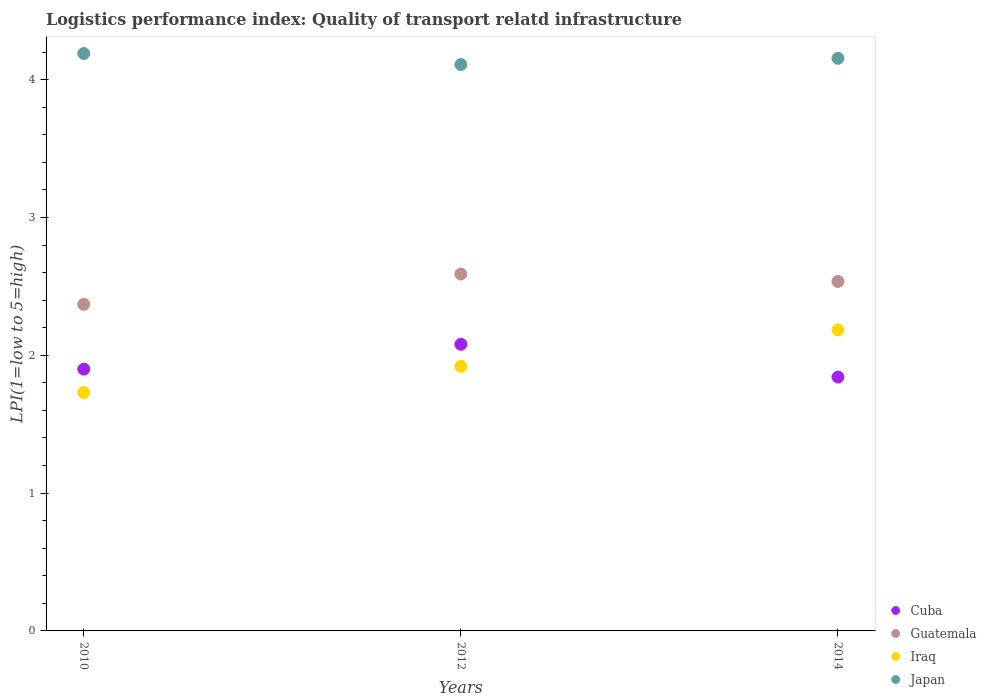How many different coloured dotlines are there?
Provide a succinct answer. 4. Is the number of dotlines equal to the number of legend labels?
Your answer should be very brief. Yes. What is the logistics performance index in Japan in 2014?
Make the answer very short. 4.16. Across all years, what is the maximum logistics performance index in Iraq?
Ensure brevity in your answer.  2.18. Across all years, what is the minimum logistics performance index in Cuba?
Give a very brief answer. 1.84. In which year was the logistics performance index in Guatemala maximum?
Ensure brevity in your answer.  2012. What is the total logistics performance index in Guatemala in the graph?
Your answer should be compact. 7.5. What is the difference between the logistics performance index in Guatemala in 2012 and that in 2014?
Your response must be concise. 0.05. What is the difference between the logistics performance index in Cuba in 2014 and the logistics performance index in Iraq in 2012?
Offer a very short reply. -0.08. What is the average logistics performance index in Cuba per year?
Provide a succinct answer. 1.94. In the year 2010, what is the difference between the logistics performance index in Iraq and logistics performance index in Japan?
Your answer should be compact. -2.46. In how many years, is the logistics performance index in Iraq greater than 0.2?
Your answer should be very brief. 3. What is the ratio of the logistics performance index in Iraq in 2012 to that in 2014?
Ensure brevity in your answer.  0.88. Is the difference between the logistics performance index in Iraq in 2012 and 2014 greater than the difference between the logistics performance index in Japan in 2012 and 2014?
Ensure brevity in your answer.  No. What is the difference between the highest and the second highest logistics performance index in Cuba?
Provide a succinct answer. 0.18. What is the difference between the highest and the lowest logistics performance index in Iraq?
Your answer should be compact. 0.45. Does the logistics performance index in Guatemala monotonically increase over the years?
Keep it short and to the point. No. How many dotlines are there?
Keep it short and to the point. 4. What is the difference between two consecutive major ticks on the Y-axis?
Ensure brevity in your answer.  1. Does the graph contain grids?
Make the answer very short. No. How many legend labels are there?
Offer a terse response. 4. What is the title of the graph?
Give a very brief answer. Logistics performance index: Quality of transport relatd infrastructure. What is the label or title of the Y-axis?
Keep it short and to the point. LPI(1=low to 5=high). What is the LPI(1=low to 5=high) in Guatemala in 2010?
Keep it short and to the point. 2.37. What is the LPI(1=low to 5=high) of Iraq in 2010?
Provide a short and direct response. 1.73. What is the LPI(1=low to 5=high) of Japan in 2010?
Provide a short and direct response. 4.19. What is the LPI(1=low to 5=high) in Cuba in 2012?
Provide a succinct answer. 2.08. What is the LPI(1=low to 5=high) in Guatemala in 2012?
Offer a very short reply. 2.59. What is the LPI(1=low to 5=high) of Iraq in 2012?
Keep it short and to the point. 1.92. What is the LPI(1=low to 5=high) in Japan in 2012?
Your answer should be very brief. 4.11. What is the LPI(1=low to 5=high) in Cuba in 2014?
Provide a succinct answer. 1.84. What is the LPI(1=low to 5=high) of Guatemala in 2014?
Your answer should be compact. 2.54. What is the LPI(1=low to 5=high) in Iraq in 2014?
Offer a terse response. 2.18. What is the LPI(1=low to 5=high) in Japan in 2014?
Offer a terse response. 4.16. Across all years, what is the maximum LPI(1=low to 5=high) of Cuba?
Provide a short and direct response. 2.08. Across all years, what is the maximum LPI(1=low to 5=high) in Guatemala?
Keep it short and to the point. 2.59. Across all years, what is the maximum LPI(1=low to 5=high) of Iraq?
Keep it short and to the point. 2.18. Across all years, what is the maximum LPI(1=low to 5=high) in Japan?
Your response must be concise. 4.19. Across all years, what is the minimum LPI(1=low to 5=high) of Cuba?
Provide a succinct answer. 1.84. Across all years, what is the minimum LPI(1=low to 5=high) of Guatemala?
Give a very brief answer. 2.37. Across all years, what is the minimum LPI(1=low to 5=high) of Iraq?
Your answer should be very brief. 1.73. Across all years, what is the minimum LPI(1=low to 5=high) in Japan?
Provide a succinct answer. 4.11. What is the total LPI(1=low to 5=high) of Cuba in the graph?
Your answer should be very brief. 5.82. What is the total LPI(1=low to 5=high) of Guatemala in the graph?
Ensure brevity in your answer.  7.5. What is the total LPI(1=low to 5=high) of Iraq in the graph?
Provide a succinct answer. 5.83. What is the total LPI(1=low to 5=high) in Japan in the graph?
Your response must be concise. 12.46. What is the difference between the LPI(1=low to 5=high) in Cuba in 2010 and that in 2012?
Offer a very short reply. -0.18. What is the difference between the LPI(1=low to 5=high) in Guatemala in 2010 and that in 2012?
Give a very brief answer. -0.22. What is the difference between the LPI(1=low to 5=high) in Iraq in 2010 and that in 2012?
Make the answer very short. -0.19. What is the difference between the LPI(1=low to 5=high) of Japan in 2010 and that in 2012?
Ensure brevity in your answer.  0.08. What is the difference between the LPI(1=low to 5=high) of Cuba in 2010 and that in 2014?
Provide a short and direct response. 0.06. What is the difference between the LPI(1=low to 5=high) of Guatemala in 2010 and that in 2014?
Make the answer very short. -0.17. What is the difference between the LPI(1=low to 5=high) in Iraq in 2010 and that in 2014?
Provide a succinct answer. -0.45. What is the difference between the LPI(1=low to 5=high) in Japan in 2010 and that in 2014?
Provide a short and direct response. 0.03. What is the difference between the LPI(1=low to 5=high) in Cuba in 2012 and that in 2014?
Provide a succinct answer. 0.24. What is the difference between the LPI(1=low to 5=high) of Guatemala in 2012 and that in 2014?
Make the answer very short. 0.05. What is the difference between the LPI(1=low to 5=high) in Iraq in 2012 and that in 2014?
Make the answer very short. -0.26. What is the difference between the LPI(1=low to 5=high) of Japan in 2012 and that in 2014?
Your answer should be compact. -0.05. What is the difference between the LPI(1=low to 5=high) in Cuba in 2010 and the LPI(1=low to 5=high) in Guatemala in 2012?
Give a very brief answer. -0.69. What is the difference between the LPI(1=low to 5=high) in Cuba in 2010 and the LPI(1=low to 5=high) in Iraq in 2012?
Your answer should be compact. -0.02. What is the difference between the LPI(1=low to 5=high) of Cuba in 2010 and the LPI(1=low to 5=high) of Japan in 2012?
Make the answer very short. -2.21. What is the difference between the LPI(1=low to 5=high) in Guatemala in 2010 and the LPI(1=low to 5=high) in Iraq in 2012?
Provide a succinct answer. 0.45. What is the difference between the LPI(1=low to 5=high) in Guatemala in 2010 and the LPI(1=low to 5=high) in Japan in 2012?
Offer a terse response. -1.74. What is the difference between the LPI(1=low to 5=high) in Iraq in 2010 and the LPI(1=low to 5=high) in Japan in 2012?
Your answer should be very brief. -2.38. What is the difference between the LPI(1=low to 5=high) of Cuba in 2010 and the LPI(1=low to 5=high) of Guatemala in 2014?
Ensure brevity in your answer.  -0.64. What is the difference between the LPI(1=low to 5=high) in Cuba in 2010 and the LPI(1=low to 5=high) in Iraq in 2014?
Your answer should be very brief. -0.28. What is the difference between the LPI(1=low to 5=high) of Cuba in 2010 and the LPI(1=low to 5=high) of Japan in 2014?
Your answer should be compact. -2.26. What is the difference between the LPI(1=low to 5=high) in Guatemala in 2010 and the LPI(1=low to 5=high) in Iraq in 2014?
Provide a succinct answer. 0.19. What is the difference between the LPI(1=low to 5=high) of Guatemala in 2010 and the LPI(1=low to 5=high) of Japan in 2014?
Make the answer very short. -1.79. What is the difference between the LPI(1=low to 5=high) of Iraq in 2010 and the LPI(1=low to 5=high) of Japan in 2014?
Make the answer very short. -2.43. What is the difference between the LPI(1=low to 5=high) of Cuba in 2012 and the LPI(1=low to 5=high) of Guatemala in 2014?
Provide a succinct answer. -0.46. What is the difference between the LPI(1=low to 5=high) in Cuba in 2012 and the LPI(1=low to 5=high) in Iraq in 2014?
Make the answer very short. -0.1. What is the difference between the LPI(1=low to 5=high) in Cuba in 2012 and the LPI(1=low to 5=high) in Japan in 2014?
Ensure brevity in your answer.  -2.08. What is the difference between the LPI(1=low to 5=high) of Guatemala in 2012 and the LPI(1=low to 5=high) of Iraq in 2014?
Keep it short and to the point. 0.41. What is the difference between the LPI(1=low to 5=high) of Guatemala in 2012 and the LPI(1=low to 5=high) of Japan in 2014?
Provide a succinct answer. -1.57. What is the difference between the LPI(1=low to 5=high) of Iraq in 2012 and the LPI(1=low to 5=high) of Japan in 2014?
Provide a short and direct response. -2.24. What is the average LPI(1=low to 5=high) of Cuba per year?
Offer a very short reply. 1.94. What is the average LPI(1=low to 5=high) of Guatemala per year?
Provide a short and direct response. 2.5. What is the average LPI(1=low to 5=high) in Iraq per year?
Provide a short and direct response. 1.94. What is the average LPI(1=low to 5=high) of Japan per year?
Your response must be concise. 4.15. In the year 2010, what is the difference between the LPI(1=low to 5=high) of Cuba and LPI(1=low to 5=high) of Guatemala?
Provide a succinct answer. -0.47. In the year 2010, what is the difference between the LPI(1=low to 5=high) in Cuba and LPI(1=low to 5=high) in Iraq?
Offer a very short reply. 0.17. In the year 2010, what is the difference between the LPI(1=low to 5=high) of Cuba and LPI(1=low to 5=high) of Japan?
Ensure brevity in your answer.  -2.29. In the year 2010, what is the difference between the LPI(1=low to 5=high) of Guatemala and LPI(1=low to 5=high) of Iraq?
Provide a succinct answer. 0.64. In the year 2010, what is the difference between the LPI(1=low to 5=high) in Guatemala and LPI(1=low to 5=high) in Japan?
Provide a succinct answer. -1.82. In the year 2010, what is the difference between the LPI(1=low to 5=high) in Iraq and LPI(1=low to 5=high) in Japan?
Your response must be concise. -2.46. In the year 2012, what is the difference between the LPI(1=low to 5=high) in Cuba and LPI(1=low to 5=high) in Guatemala?
Offer a very short reply. -0.51. In the year 2012, what is the difference between the LPI(1=low to 5=high) of Cuba and LPI(1=low to 5=high) of Iraq?
Ensure brevity in your answer.  0.16. In the year 2012, what is the difference between the LPI(1=low to 5=high) of Cuba and LPI(1=low to 5=high) of Japan?
Offer a terse response. -2.03. In the year 2012, what is the difference between the LPI(1=low to 5=high) of Guatemala and LPI(1=low to 5=high) of Iraq?
Ensure brevity in your answer.  0.67. In the year 2012, what is the difference between the LPI(1=low to 5=high) in Guatemala and LPI(1=low to 5=high) in Japan?
Offer a very short reply. -1.52. In the year 2012, what is the difference between the LPI(1=low to 5=high) in Iraq and LPI(1=low to 5=high) in Japan?
Give a very brief answer. -2.19. In the year 2014, what is the difference between the LPI(1=low to 5=high) in Cuba and LPI(1=low to 5=high) in Guatemala?
Give a very brief answer. -0.69. In the year 2014, what is the difference between the LPI(1=low to 5=high) in Cuba and LPI(1=low to 5=high) in Iraq?
Offer a very short reply. -0.34. In the year 2014, what is the difference between the LPI(1=low to 5=high) of Cuba and LPI(1=low to 5=high) of Japan?
Provide a short and direct response. -2.31. In the year 2014, what is the difference between the LPI(1=low to 5=high) in Guatemala and LPI(1=low to 5=high) in Iraq?
Ensure brevity in your answer.  0.35. In the year 2014, what is the difference between the LPI(1=low to 5=high) of Guatemala and LPI(1=low to 5=high) of Japan?
Ensure brevity in your answer.  -1.62. In the year 2014, what is the difference between the LPI(1=low to 5=high) of Iraq and LPI(1=low to 5=high) of Japan?
Keep it short and to the point. -1.97. What is the ratio of the LPI(1=low to 5=high) of Cuba in 2010 to that in 2012?
Your response must be concise. 0.91. What is the ratio of the LPI(1=low to 5=high) of Guatemala in 2010 to that in 2012?
Keep it short and to the point. 0.92. What is the ratio of the LPI(1=low to 5=high) of Iraq in 2010 to that in 2012?
Your answer should be compact. 0.9. What is the ratio of the LPI(1=low to 5=high) of Japan in 2010 to that in 2012?
Give a very brief answer. 1.02. What is the ratio of the LPI(1=low to 5=high) in Cuba in 2010 to that in 2014?
Provide a short and direct response. 1.03. What is the ratio of the LPI(1=low to 5=high) of Guatemala in 2010 to that in 2014?
Offer a terse response. 0.93. What is the ratio of the LPI(1=low to 5=high) in Iraq in 2010 to that in 2014?
Provide a succinct answer. 0.79. What is the ratio of the LPI(1=low to 5=high) in Japan in 2010 to that in 2014?
Give a very brief answer. 1.01. What is the ratio of the LPI(1=low to 5=high) of Cuba in 2012 to that in 2014?
Make the answer very short. 1.13. What is the ratio of the LPI(1=low to 5=high) in Guatemala in 2012 to that in 2014?
Make the answer very short. 1.02. What is the ratio of the LPI(1=low to 5=high) of Iraq in 2012 to that in 2014?
Provide a short and direct response. 0.88. What is the ratio of the LPI(1=low to 5=high) of Japan in 2012 to that in 2014?
Provide a succinct answer. 0.99. What is the difference between the highest and the second highest LPI(1=low to 5=high) of Cuba?
Provide a succinct answer. 0.18. What is the difference between the highest and the second highest LPI(1=low to 5=high) in Guatemala?
Make the answer very short. 0.05. What is the difference between the highest and the second highest LPI(1=low to 5=high) of Iraq?
Your response must be concise. 0.26. What is the difference between the highest and the second highest LPI(1=low to 5=high) in Japan?
Your response must be concise. 0.03. What is the difference between the highest and the lowest LPI(1=low to 5=high) in Cuba?
Offer a terse response. 0.24. What is the difference between the highest and the lowest LPI(1=low to 5=high) in Guatemala?
Make the answer very short. 0.22. What is the difference between the highest and the lowest LPI(1=low to 5=high) in Iraq?
Make the answer very short. 0.45. 